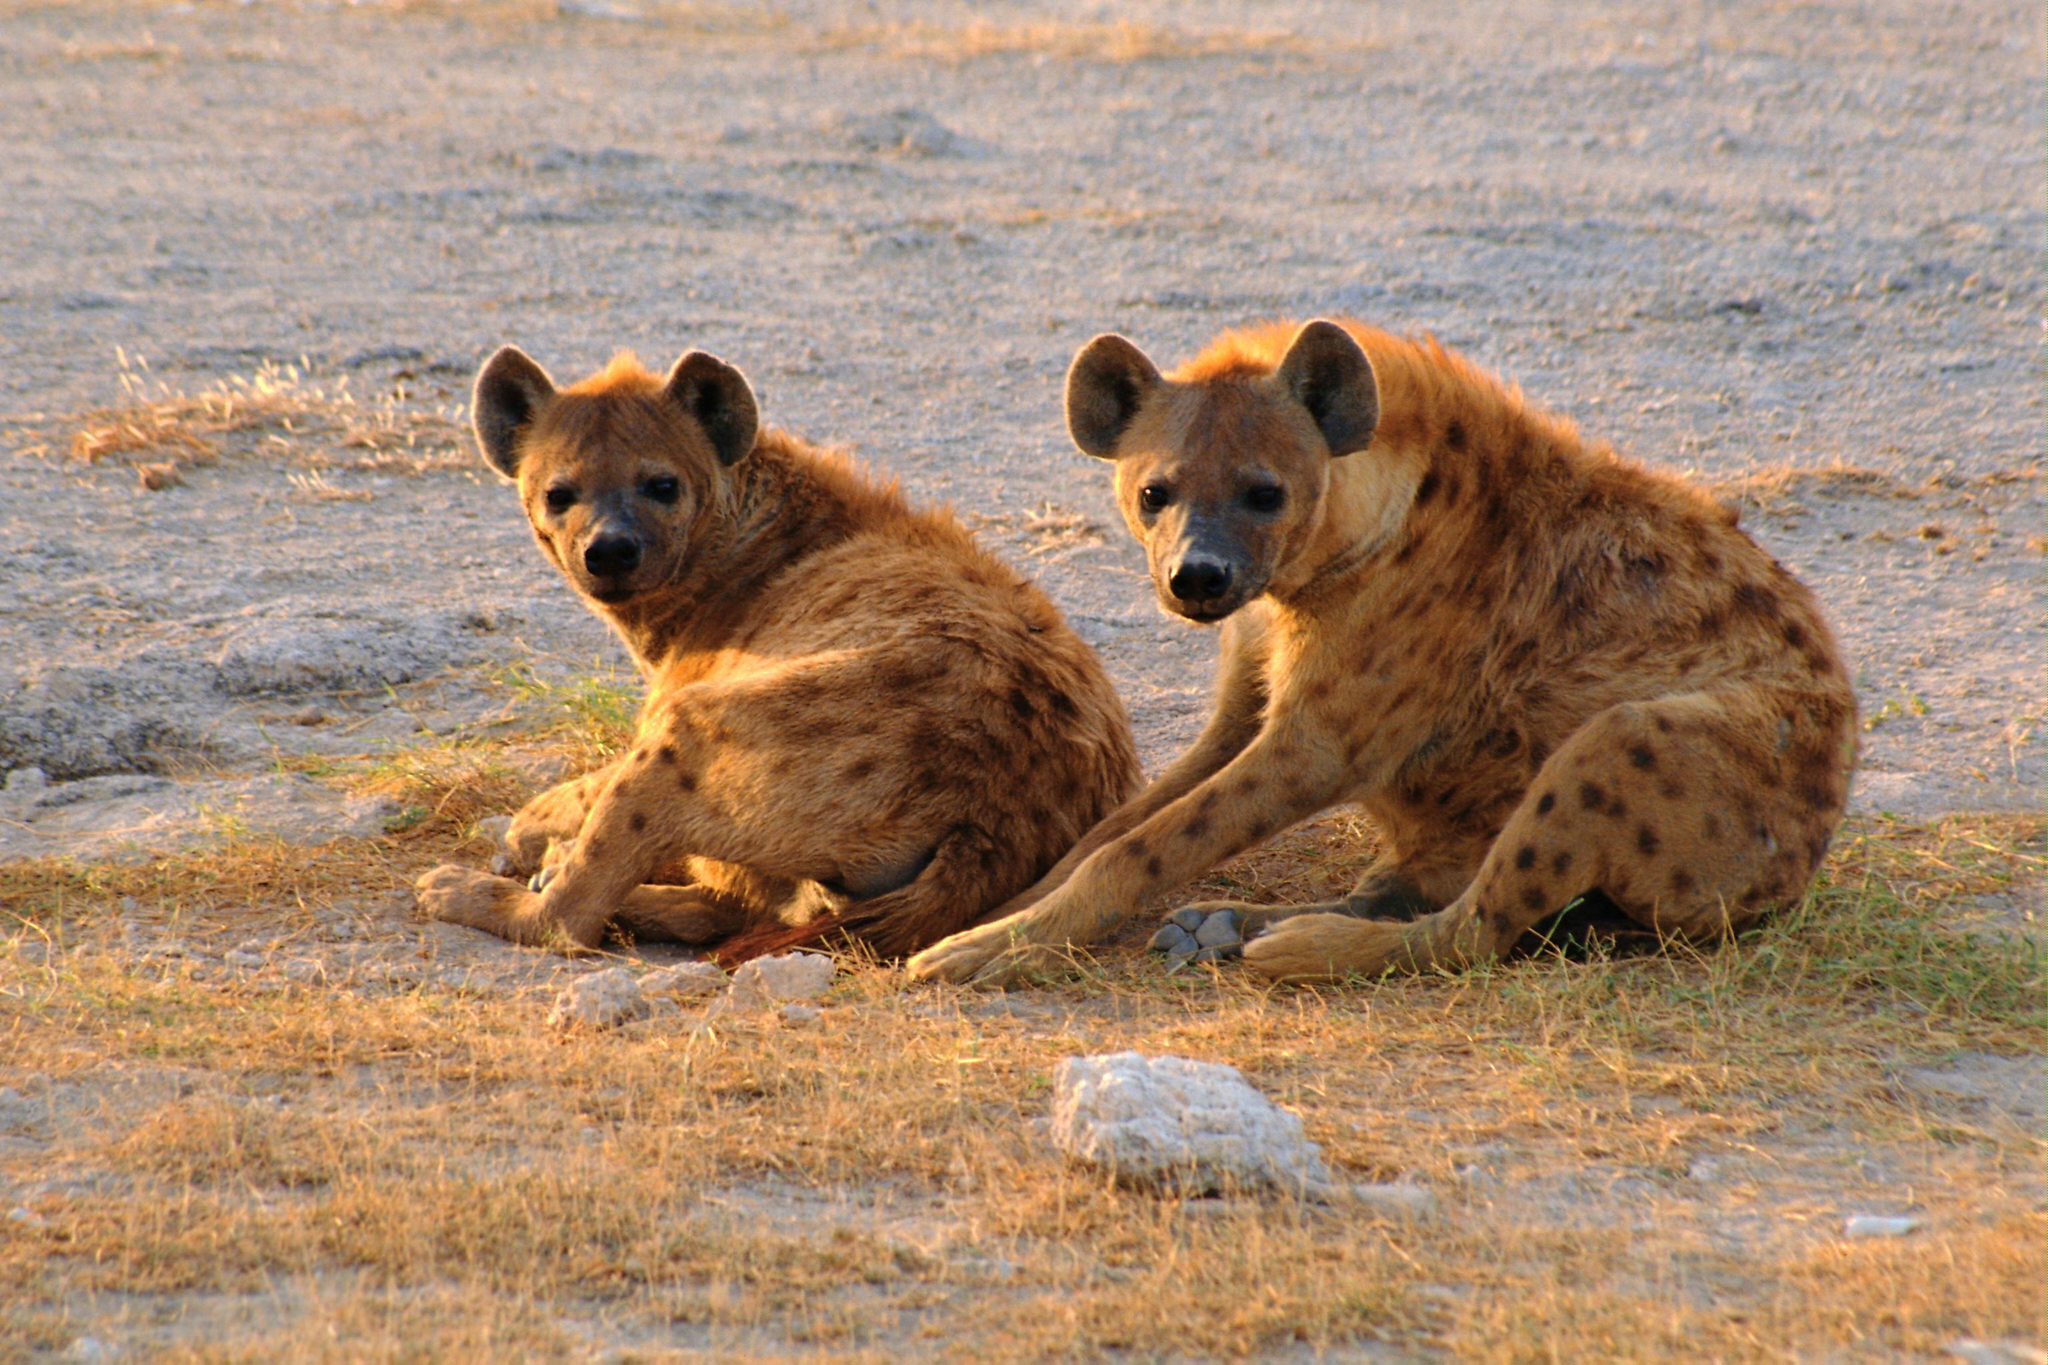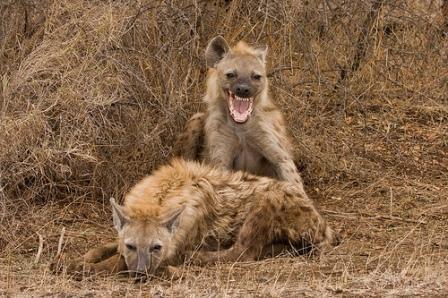The first image is the image on the left, the second image is the image on the right. Evaluate the accuracy of this statement regarding the images: "Exactly one hyena's teeth are visible.". Is it true? Answer yes or no. Yes. The first image is the image on the left, the second image is the image on the right. Analyze the images presented: Is the assertion "Exactly one hyena is baring its fangs with wide-opened mouth, and no image shows hyenas posed face-to-face." valid? Answer yes or no. Yes. 